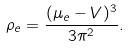Convert formula to latex. <formula><loc_0><loc_0><loc_500><loc_500>\rho _ { e } = \frac { ( \mu _ { e } - V ) ^ { 3 } } { 3 \pi ^ { 2 } } .</formula> 